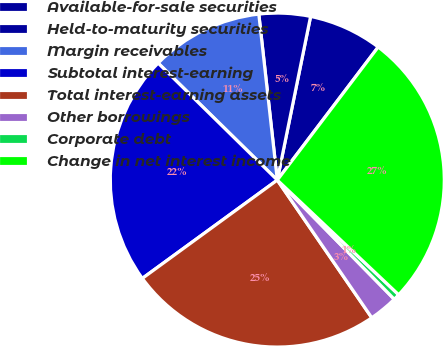<chart> <loc_0><loc_0><loc_500><loc_500><pie_chart><fcel>Available-for-sale securities<fcel>Held-to-maturity securities<fcel>Margin receivables<fcel>Subtotal interest-earning<fcel>Total interest-earning assets<fcel>Other borrowings<fcel>Corporate debt<fcel>Change in net interest income<nl><fcel>7.13%<fcel>4.96%<fcel>10.88%<fcel>22.37%<fcel>24.55%<fcel>2.78%<fcel>0.6%<fcel>26.72%<nl></chart> 